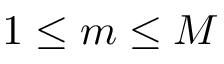<formula> <loc_0><loc_0><loc_500><loc_500>1 \leq m \leq M</formula> 